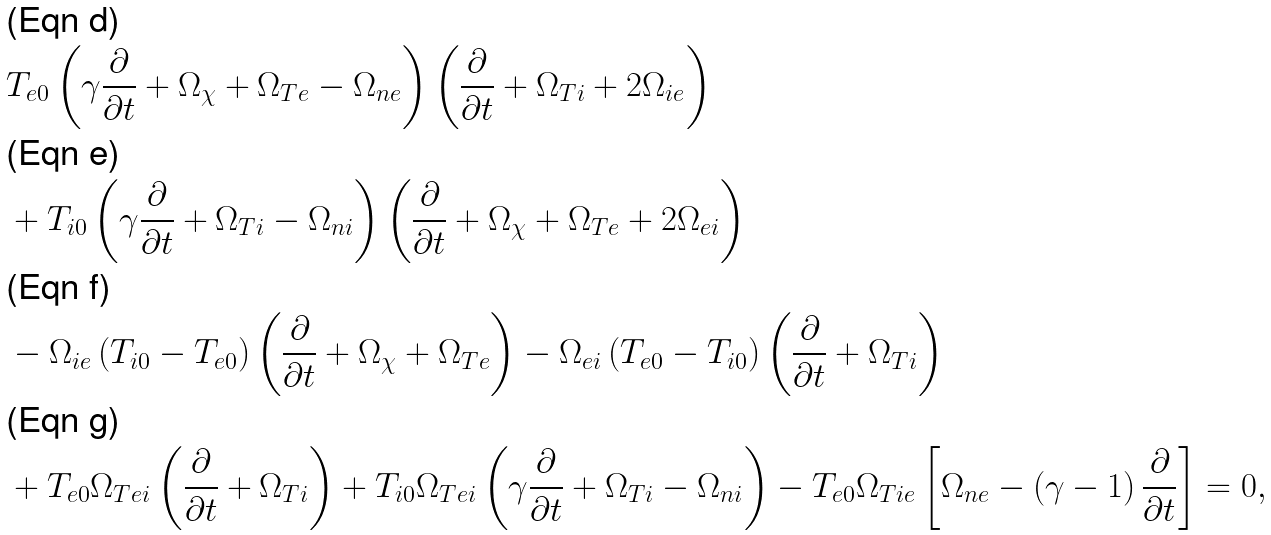Convert formula to latex. <formula><loc_0><loc_0><loc_500><loc_500>& T _ { e 0 } \left ( \gamma \frac { \partial } { \partial t } + \Omega _ { \chi } + \Omega _ { T e } - \Omega _ { n e } \right ) \left ( \frac { \partial } { \partial t } + \Omega _ { T i } + 2 \Omega _ { i e } \right ) \\ & + T _ { i 0 } \left ( \gamma \frac { \partial } { \partial t } + \Omega _ { T i } - \Omega _ { n i } \right ) \left ( \frac { \partial } { \partial t } + \Omega _ { \chi } + \Omega _ { T e } + 2 \Omega _ { e i } \right ) \\ & - \Omega _ { i e } \left ( T _ { i 0 } - T _ { e 0 } \right ) \left ( \frac { \partial } { \partial t } + \Omega _ { \chi } + \Omega _ { T e } \right ) - \Omega _ { e i } \left ( T _ { e 0 } - T _ { i 0 } \right ) \left ( \frac { \partial } { \partial t } + \Omega _ { T i } \right ) \\ & + T _ { e 0 } \Omega _ { T e i } \left ( \frac { \partial } { \partial t } + \Omega _ { T i } \right ) + T _ { i 0 } \Omega _ { T e i } \left ( \gamma \frac { \partial } { \partial t } + \Omega _ { T i } - \Omega _ { n i } \right ) - T _ { e 0 } \Omega _ { T i e } \left [ \Omega _ { n e } - \left ( \gamma - 1 \right ) \frac { \partial } { \partial t } \right ] = 0 ,</formula> 